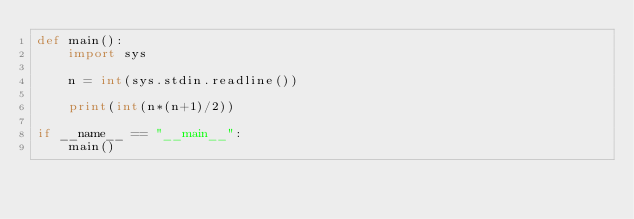Convert code to text. <code><loc_0><loc_0><loc_500><loc_500><_Python_>def main():
    import sys
    
    n = int(sys.stdin.readline())
    
    print(int(n*(n+1)/2))
    
if __name__ == "__main__":
    main()</code> 